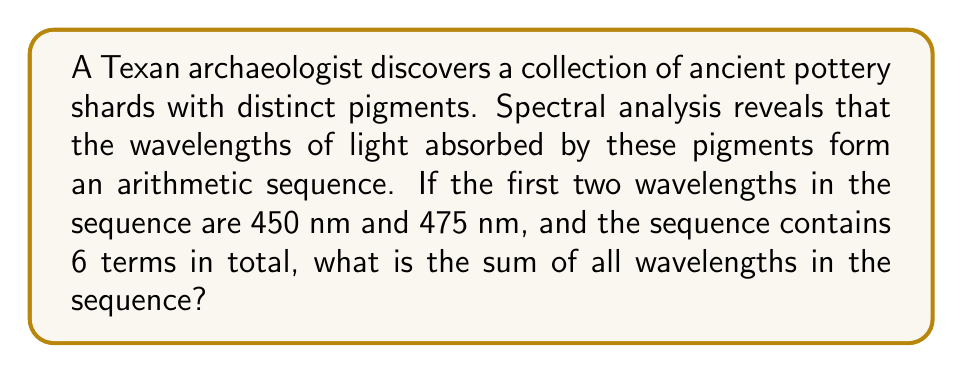Provide a solution to this math problem. Let's approach this step-by-step:

1) First, we need to identify the arithmetic sequence. We're given that the first two terms are 450 nm and 475 nm.

2) In an arithmetic sequence, the difference between any two consecutive terms is constant. Let's call this common difference $d$. We can find $d$ by subtracting the first term from the second:

   $d = 475 - 450 = 25$ nm

3) Now we know that the sequence is: 450, 475, ..., with a common difference of 25 nm.

4) The general formula for the $n$-th term of an arithmetic sequence is:

   $a_n = a_1 + (n-1)d$

   Where $a_1$ is the first term, $n$ is the position of the term, and $d$ is the common difference.

5) We're told there are 6 terms in total. So the last term (6th term) would be:

   $a_6 = 450 + (6-1)25 = 450 + 125 = 575$ nm

6) To find the sum of all terms, we can use the formula for the sum of an arithmetic sequence:

   $S_n = \frac{n}{2}(a_1 + a_n)$

   Where $S_n$ is the sum of $n$ terms, $a_1$ is the first term, and $a_n$ is the last term.

7) Plugging in our values:

   $S_6 = \frac{6}{2}(450 + 575) = 3(1025) = 3075$ nm

Therefore, the sum of all wavelengths in the sequence is 3075 nm.
Answer: 3075 nm 